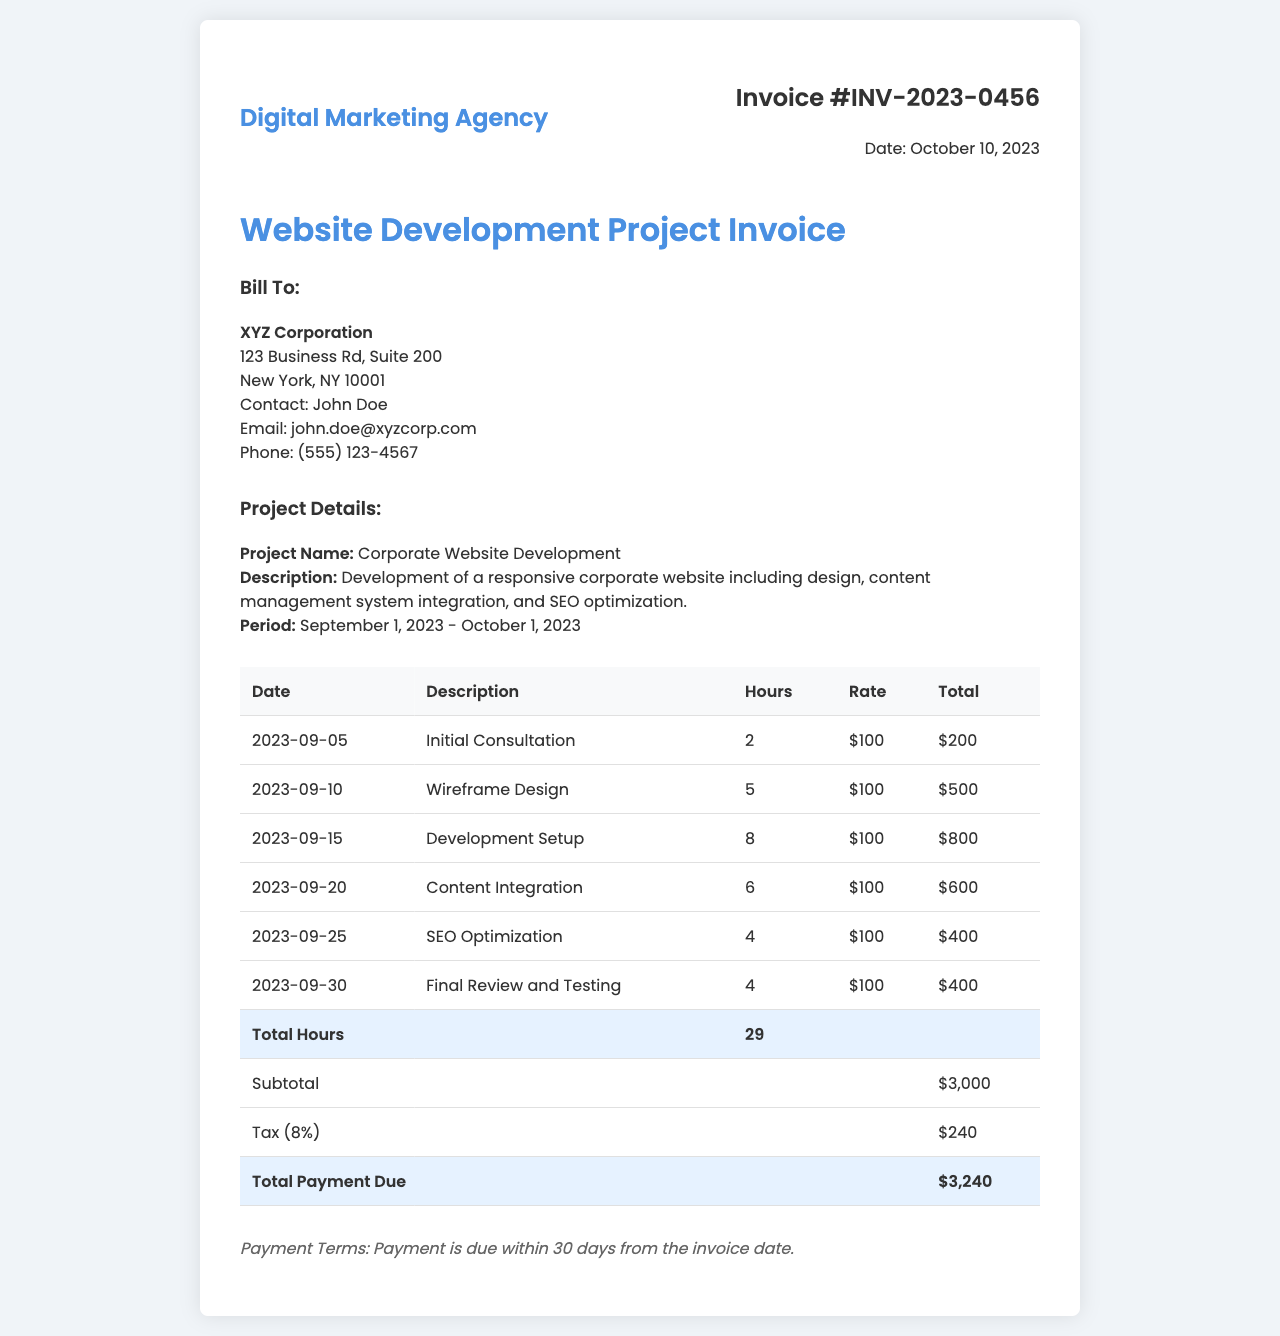What is the invoice number? The invoice number is prominently displayed in the header of the document.
Answer: INV-2023-0456 Who is the client? The recipient's information is provided under the "Bill To" section, specifically naming the company.
Answer: XYZ Corporation What is the total payment due? The total payment due is calculated at the end of the table in the invoice.
Answer: $3,240 How many total hours were worked? The total number of hours worked is summarized in the last part of the table.
Answer: 29 What is the tax percentage applied? The tax amount can be found in the invoice, and it reflects a specific percentage of the subtotal.
Answer: 8% When was the invoice issued? The date of the invoice is stated in the header section among the invoice details.
Answer: October 10, 2023 What is the project name? The project name is stated under the "Project Details" section.
Answer: Corporate Website Development What service was provided on September 20, 2023? The date and description of services rendered are detailed in the table section.
Answer: Content Integration What is the payment term? The payment terms are mentioned towards the end of the document, outlining when payment should be made.
Answer: Payment is due within 30 days from the invoice date 